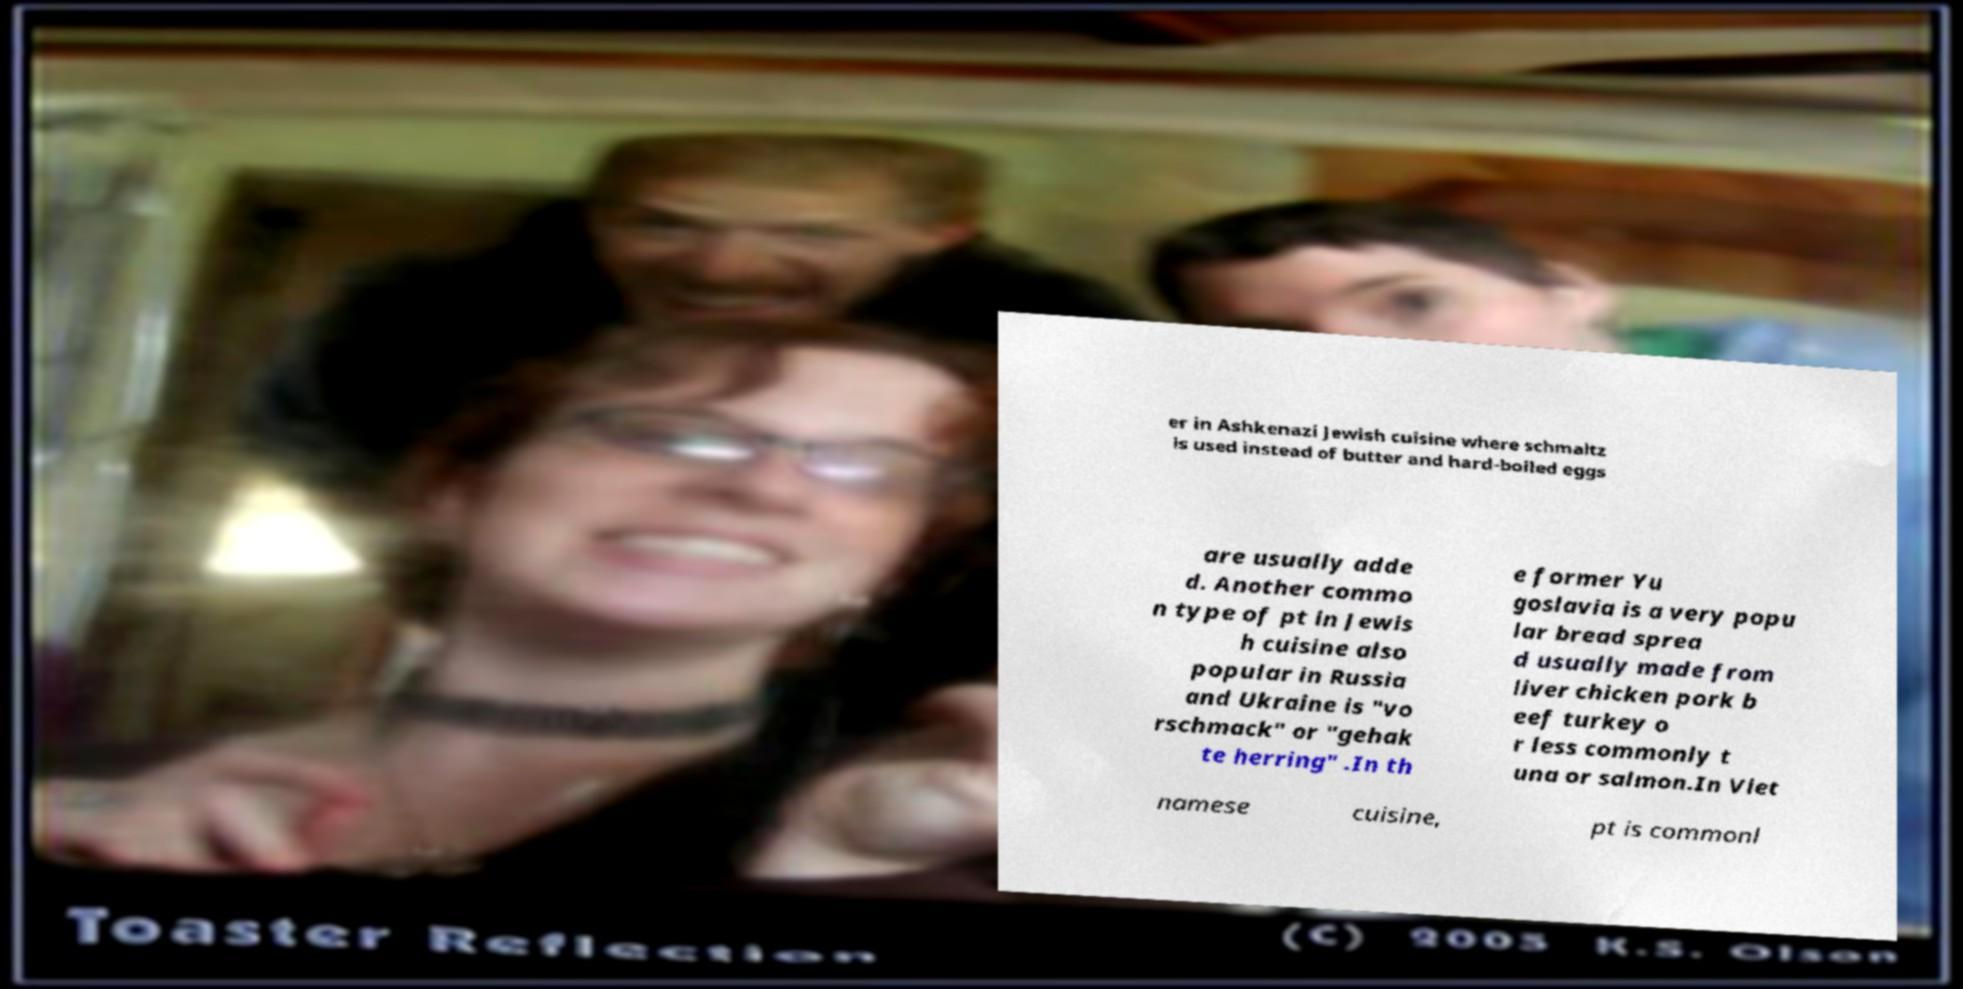I need the written content from this picture converted into text. Can you do that? er in Ashkenazi Jewish cuisine where schmaltz is used instead of butter and hard-boiled eggs are usually adde d. Another commo n type of pt in Jewis h cuisine also popular in Russia and Ukraine is "vo rschmack" or "gehak te herring" .In th e former Yu goslavia is a very popu lar bread sprea d usually made from liver chicken pork b eef turkey o r less commonly t una or salmon.In Viet namese cuisine, pt is commonl 